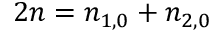Convert formula to latex. <formula><loc_0><loc_0><loc_500><loc_500>2 n = n _ { 1 , 0 } + n _ { 2 , 0 }</formula> 